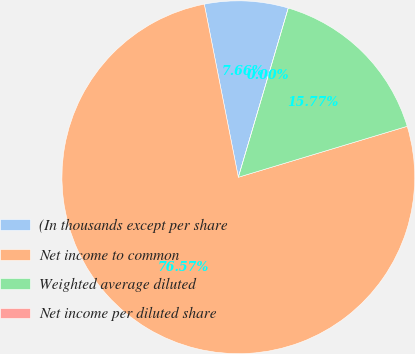<chart> <loc_0><loc_0><loc_500><loc_500><pie_chart><fcel>(In thousands except per share<fcel>Net income to common<fcel>Weighted average diluted<fcel>Net income per diluted share<nl><fcel>7.66%<fcel>76.57%<fcel>15.77%<fcel>0.0%<nl></chart> 